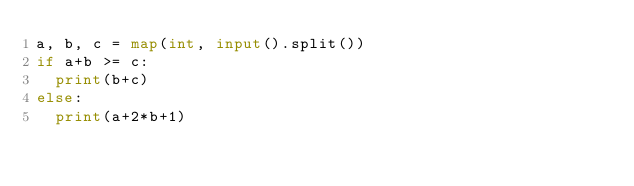<code> <loc_0><loc_0><loc_500><loc_500><_Python_>a, b, c = map(int, input().split())
if a+b >= c:
  print(b+c)
else:
  print(a+2*b+1)</code> 